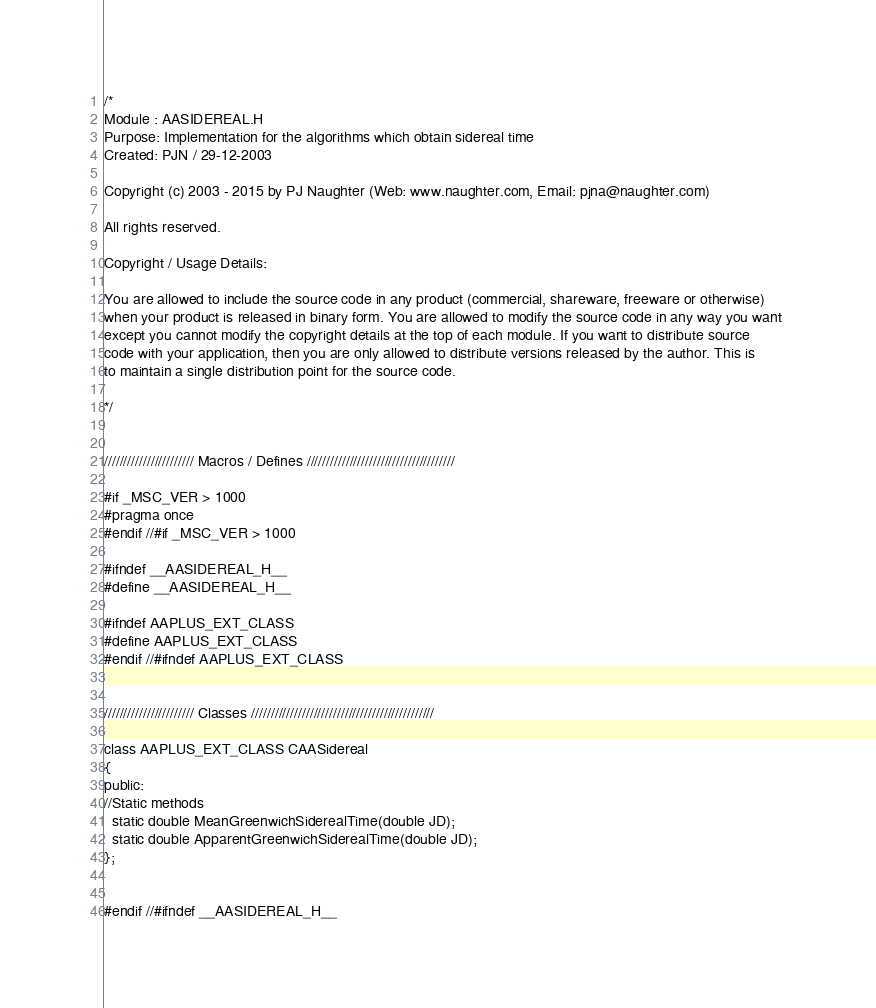Convert code to text. <code><loc_0><loc_0><loc_500><loc_500><_C_>/*
Module : AASIDEREAL.H
Purpose: Implementation for the algorithms which obtain sidereal time
Created: PJN / 29-12-2003

Copyright (c) 2003 - 2015 by PJ Naughter (Web: www.naughter.com, Email: pjna@naughter.com)

All rights reserved.

Copyright / Usage Details:

You are allowed to include the source code in any product (commercial, shareware, freeware or otherwise) 
when your product is released in binary form. You are allowed to modify the source code in any way you want 
except you cannot modify the copyright details at the top of each module. If you want to distribute source 
code with your application, then you are only allowed to distribute versions released by the author. This is 
to maintain a single distribution point for the source code. 

*/


/////////////////////// Macros / Defines //////////////////////////////////////

#if _MSC_VER > 1000
#pragma once
#endif //#if _MSC_VER > 1000

#ifndef __AASIDEREAL_H__
#define __AASIDEREAL_H__

#ifndef AAPLUS_EXT_CLASS
#define AAPLUS_EXT_CLASS
#endif //#ifndef AAPLUS_EXT_CLASS


/////////////////////// Classes ///////////////////////////////////////////////

class AAPLUS_EXT_CLASS CAASidereal
{
public:
//Static methods
  static double MeanGreenwichSiderealTime(double JD);
  static double ApparentGreenwichSiderealTime(double JD);
};


#endif //#ifndef __AASIDEREAL_H__
</code> 